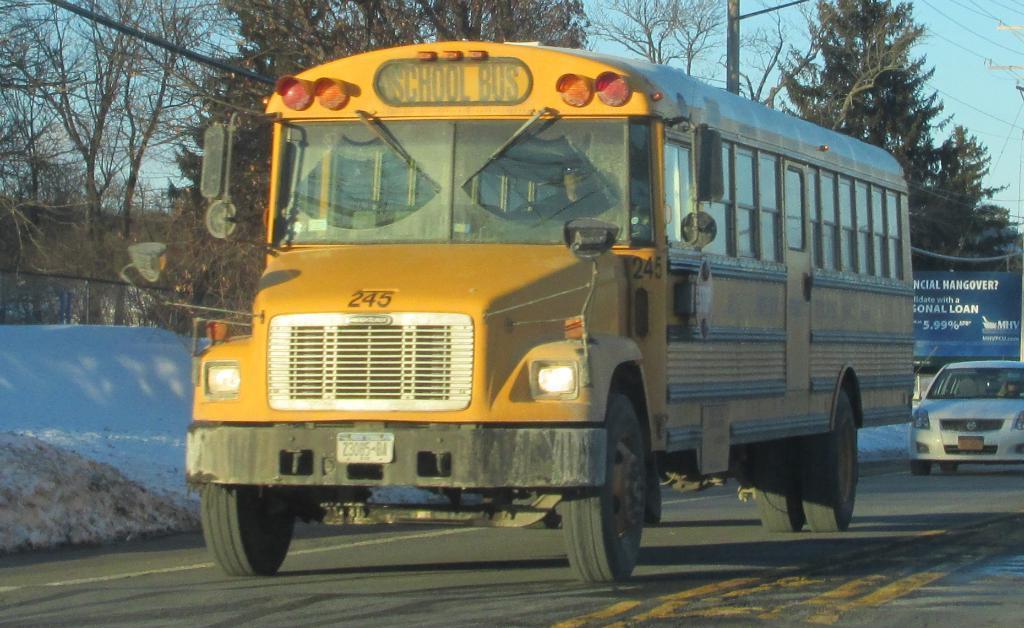Describe this image in one or two sentences. In this image there are vehicles on the road. On the left side of the image there is snow on the surface. In the background of the image there are trees. There is a board. There are current poles and sky. 